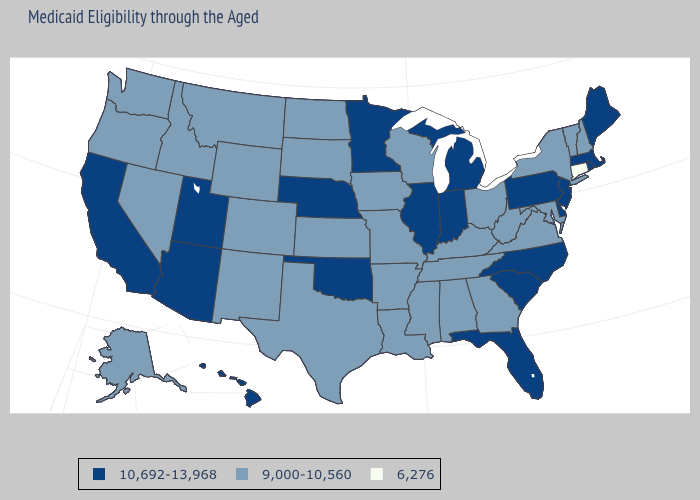Does Oregon have the lowest value in the West?
Keep it brief. Yes. What is the value of Delaware?
Short answer required. 10,692-13,968. Does Oklahoma have the lowest value in the South?
Write a very short answer. No. Does Maine have the same value as North Carolina?
Concise answer only. Yes. Name the states that have a value in the range 9,000-10,560?
Answer briefly. Alabama, Alaska, Arkansas, Colorado, Georgia, Idaho, Iowa, Kansas, Kentucky, Louisiana, Maryland, Mississippi, Missouri, Montana, Nevada, New Hampshire, New Mexico, New York, North Dakota, Ohio, Oregon, South Dakota, Tennessee, Texas, Vermont, Virginia, Washington, West Virginia, Wisconsin, Wyoming. Is the legend a continuous bar?
Keep it brief. No. Name the states that have a value in the range 9,000-10,560?
Be succinct. Alabama, Alaska, Arkansas, Colorado, Georgia, Idaho, Iowa, Kansas, Kentucky, Louisiana, Maryland, Mississippi, Missouri, Montana, Nevada, New Hampshire, New Mexico, New York, North Dakota, Ohio, Oregon, South Dakota, Tennessee, Texas, Vermont, Virginia, Washington, West Virginia, Wisconsin, Wyoming. Name the states that have a value in the range 6,276?
Concise answer only. Connecticut. What is the value of Indiana?
Be succinct. 10,692-13,968. What is the highest value in the USA?
Be succinct. 10,692-13,968. Does Georgia have the highest value in the South?
Answer briefly. No. Which states have the lowest value in the South?
Be succinct. Alabama, Arkansas, Georgia, Kentucky, Louisiana, Maryland, Mississippi, Tennessee, Texas, Virginia, West Virginia. Name the states that have a value in the range 9,000-10,560?
Be succinct. Alabama, Alaska, Arkansas, Colorado, Georgia, Idaho, Iowa, Kansas, Kentucky, Louisiana, Maryland, Mississippi, Missouri, Montana, Nevada, New Hampshire, New Mexico, New York, North Dakota, Ohio, Oregon, South Dakota, Tennessee, Texas, Vermont, Virginia, Washington, West Virginia, Wisconsin, Wyoming. 